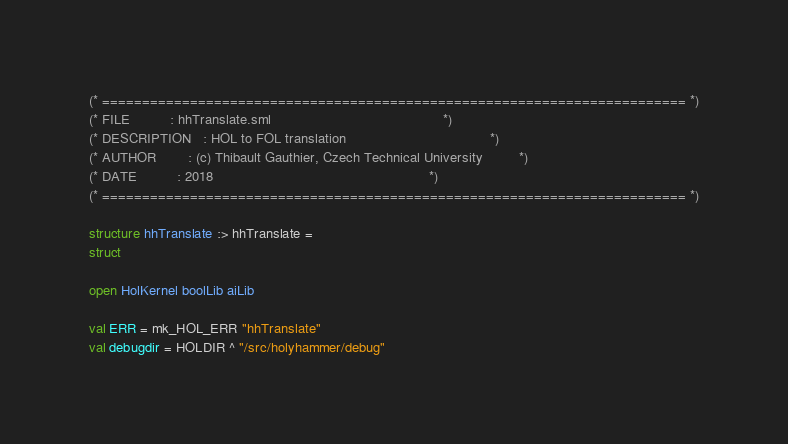Convert code to text. <code><loc_0><loc_0><loc_500><loc_500><_SML_>(* ========================================================================= *)
(* FILE          : hhTranslate.sml                                           *)
(* DESCRIPTION   : HOL to FOL translation                                    *)
(* AUTHOR        : (c) Thibault Gauthier, Czech Technical University         *)
(* DATE          : 2018                                                      *)
(* ========================================================================= *)

structure hhTranslate :> hhTranslate =
struct

open HolKernel boolLib aiLib

val ERR = mk_HOL_ERR "hhTranslate"
val debugdir = HOLDIR ^ "/src/holyhammer/debug"</code> 